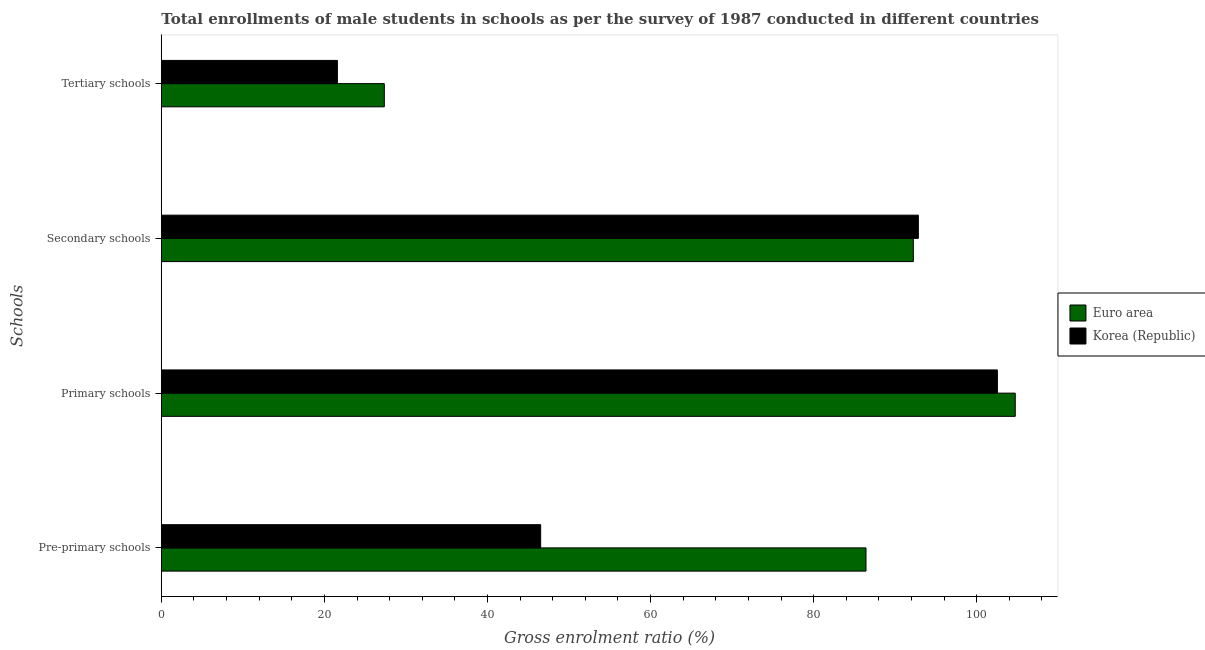How many different coloured bars are there?
Offer a terse response. 2. How many bars are there on the 1st tick from the top?
Your answer should be compact. 2. How many bars are there on the 3rd tick from the bottom?
Your answer should be very brief. 2. What is the label of the 3rd group of bars from the top?
Your response must be concise. Primary schools. What is the gross enrolment ratio(male) in secondary schools in Euro area?
Provide a succinct answer. 92.23. Across all countries, what is the maximum gross enrolment ratio(male) in secondary schools?
Your answer should be very brief. 92.85. Across all countries, what is the minimum gross enrolment ratio(male) in pre-primary schools?
Your answer should be compact. 46.52. In which country was the gross enrolment ratio(male) in secondary schools maximum?
Provide a short and direct response. Korea (Republic). What is the total gross enrolment ratio(male) in tertiary schools in the graph?
Offer a terse response. 48.94. What is the difference between the gross enrolment ratio(male) in primary schools in Euro area and that in Korea (Republic)?
Provide a short and direct response. 2.19. What is the difference between the gross enrolment ratio(male) in secondary schools in Euro area and the gross enrolment ratio(male) in pre-primary schools in Korea (Republic)?
Ensure brevity in your answer.  45.71. What is the average gross enrolment ratio(male) in secondary schools per country?
Your response must be concise. 92.54. What is the difference between the gross enrolment ratio(male) in primary schools and gross enrolment ratio(male) in pre-primary schools in Euro area?
Ensure brevity in your answer.  18.3. What is the ratio of the gross enrolment ratio(male) in secondary schools in Korea (Republic) to that in Euro area?
Ensure brevity in your answer.  1.01. Is the gross enrolment ratio(male) in primary schools in Korea (Republic) less than that in Euro area?
Provide a succinct answer. Yes. What is the difference between the highest and the second highest gross enrolment ratio(male) in primary schools?
Make the answer very short. 2.19. What is the difference between the highest and the lowest gross enrolment ratio(male) in pre-primary schools?
Your response must be concise. 39.9. In how many countries, is the gross enrolment ratio(male) in tertiary schools greater than the average gross enrolment ratio(male) in tertiary schools taken over all countries?
Give a very brief answer. 1. Is the sum of the gross enrolment ratio(male) in pre-primary schools in Euro area and Korea (Republic) greater than the maximum gross enrolment ratio(male) in primary schools across all countries?
Your answer should be very brief. Yes. Is it the case that in every country, the sum of the gross enrolment ratio(male) in tertiary schools and gross enrolment ratio(male) in secondary schools is greater than the sum of gross enrolment ratio(male) in pre-primary schools and gross enrolment ratio(male) in primary schools?
Offer a terse response. Yes. What does the 2nd bar from the bottom in Tertiary schools represents?
Your answer should be very brief. Korea (Republic). What is the difference between two consecutive major ticks on the X-axis?
Ensure brevity in your answer.  20. Does the graph contain any zero values?
Ensure brevity in your answer.  No. Where does the legend appear in the graph?
Provide a succinct answer. Center right. What is the title of the graph?
Give a very brief answer. Total enrollments of male students in schools as per the survey of 1987 conducted in different countries. Does "Senegal" appear as one of the legend labels in the graph?
Give a very brief answer. No. What is the label or title of the Y-axis?
Provide a short and direct response. Schools. What is the Gross enrolment ratio (%) in Euro area in Pre-primary schools?
Make the answer very short. 86.42. What is the Gross enrolment ratio (%) in Korea (Republic) in Pre-primary schools?
Keep it short and to the point. 46.52. What is the Gross enrolment ratio (%) in Euro area in Primary schools?
Provide a short and direct response. 104.73. What is the Gross enrolment ratio (%) in Korea (Republic) in Primary schools?
Give a very brief answer. 102.54. What is the Gross enrolment ratio (%) of Euro area in Secondary schools?
Your answer should be very brief. 92.23. What is the Gross enrolment ratio (%) of Korea (Republic) in Secondary schools?
Offer a very short reply. 92.85. What is the Gross enrolment ratio (%) in Euro area in Tertiary schools?
Offer a very short reply. 27.35. What is the Gross enrolment ratio (%) of Korea (Republic) in Tertiary schools?
Your answer should be compact. 21.59. Across all Schools, what is the maximum Gross enrolment ratio (%) in Euro area?
Your response must be concise. 104.73. Across all Schools, what is the maximum Gross enrolment ratio (%) in Korea (Republic)?
Give a very brief answer. 102.54. Across all Schools, what is the minimum Gross enrolment ratio (%) in Euro area?
Ensure brevity in your answer.  27.35. Across all Schools, what is the minimum Gross enrolment ratio (%) of Korea (Republic)?
Offer a terse response. 21.59. What is the total Gross enrolment ratio (%) of Euro area in the graph?
Keep it short and to the point. 310.73. What is the total Gross enrolment ratio (%) in Korea (Republic) in the graph?
Ensure brevity in your answer.  263.5. What is the difference between the Gross enrolment ratio (%) of Euro area in Pre-primary schools and that in Primary schools?
Offer a very short reply. -18.3. What is the difference between the Gross enrolment ratio (%) of Korea (Republic) in Pre-primary schools and that in Primary schools?
Your answer should be very brief. -56.01. What is the difference between the Gross enrolment ratio (%) of Euro area in Pre-primary schools and that in Secondary schools?
Offer a terse response. -5.81. What is the difference between the Gross enrolment ratio (%) of Korea (Republic) in Pre-primary schools and that in Secondary schools?
Provide a succinct answer. -46.32. What is the difference between the Gross enrolment ratio (%) in Euro area in Pre-primary schools and that in Tertiary schools?
Your answer should be very brief. 59.07. What is the difference between the Gross enrolment ratio (%) in Korea (Republic) in Pre-primary schools and that in Tertiary schools?
Your answer should be compact. 24.93. What is the difference between the Gross enrolment ratio (%) in Euro area in Primary schools and that in Secondary schools?
Make the answer very short. 12.5. What is the difference between the Gross enrolment ratio (%) of Korea (Republic) in Primary schools and that in Secondary schools?
Offer a very short reply. 9.69. What is the difference between the Gross enrolment ratio (%) in Euro area in Primary schools and that in Tertiary schools?
Offer a terse response. 77.38. What is the difference between the Gross enrolment ratio (%) in Korea (Republic) in Primary schools and that in Tertiary schools?
Keep it short and to the point. 80.94. What is the difference between the Gross enrolment ratio (%) in Euro area in Secondary schools and that in Tertiary schools?
Make the answer very short. 64.88. What is the difference between the Gross enrolment ratio (%) in Korea (Republic) in Secondary schools and that in Tertiary schools?
Your answer should be very brief. 71.25. What is the difference between the Gross enrolment ratio (%) of Euro area in Pre-primary schools and the Gross enrolment ratio (%) of Korea (Republic) in Primary schools?
Provide a succinct answer. -16.11. What is the difference between the Gross enrolment ratio (%) in Euro area in Pre-primary schools and the Gross enrolment ratio (%) in Korea (Republic) in Secondary schools?
Your answer should be very brief. -6.42. What is the difference between the Gross enrolment ratio (%) of Euro area in Pre-primary schools and the Gross enrolment ratio (%) of Korea (Republic) in Tertiary schools?
Provide a succinct answer. 64.83. What is the difference between the Gross enrolment ratio (%) of Euro area in Primary schools and the Gross enrolment ratio (%) of Korea (Republic) in Secondary schools?
Your answer should be very brief. 11.88. What is the difference between the Gross enrolment ratio (%) in Euro area in Primary schools and the Gross enrolment ratio (%) in Korea (Republic) in Tertiary schools?
Provide a short and direct response. 83.13. What is the difference between the Gross enrolment ratio (%) in Euro area in Secondary schools and the Gross enrolment ratio (%) in Korea (Republic) in Tertiary schools?
Your answer should be compact. 70.64. What is the average Gross enrolment ratio (%) in Euro area per Schools?
Offer a very short reply. 77.68. What is the average Gross enrolment ratio (%) of Korea (Republic) per Schools?
Offer a very short reply. 65.88. What is the difference between the Gross enrolment ratio (%) in Euro area and Gross enrolment ratio (%) in Korea (Republic) in Pre-primary schools?
Provide a succinct answer. 39.9. What is the difference between the Gross enrolment ratio (%) of Euro area and Gross enrolment ratio (%) of Korea (Republic) in Primary schools?
Keep it short and to the point. 2.19. What is the difference between the Gross enrolment ratio (%) of Euro area and Gross enrolment ratio (%) of Korea (Republic) in Secondary schools?
Your response must be concise. -0.62. What is the difference between the Gross enrolment ratio (%) in Euro area and Gross enrolment ratio (%) in Korea (Republic) in Tertiary schools?
Ensure brevity in your answer.  5.75. What is the ratio of the Gross enrolment ratio (%) of Euro area in Pre-primary schools to that in Primary schools?
Offer a terse response. 0.83. What is the ratio of the Gross enrolment ratio (%) in Korea (Republic) in Pre-primary schools to that in Primary schools?
Provide a succinct answer. 0.45. What is the ratio of the Gross enrolment ratio (%) of Euro area in Pre-primary schools to that in Secondary schools?
Offer a terse response. 0.94. What is the ratio of the Gross enrolment ratio (%) of Korea (Republic) in Pre-primary schools to that in Secondary schools?
Your answer should be compact. 0.5. What is the ratio of the Gross enrolment ratio (%) in Euro area in Pre-primary schools to that in Tertiary schools?
Make the answer very short. 3.16. What is the ratio of the Gross enrolment ratio (%) in Korea (Republic) in Pre-primary schools to that in Tertiary schools?
Give a very brief answer. 2.15. What is the ratio of the Gross enrolment ratio (%) in Euro area in Primary schools to that in Secondary schools?
Make the answer very short. 1.14. What is the ratio of the Gross enrolment ratio (%) in Korea (Republic) in Primary schools to that in Secondary schools?
Your answer should be very brief. 1.1. What is the ratio of the Gross enrolment ratio (%) in Euro area in Primary schools to that in Tertiary schools?
Offer a terse response. 3.83. What is the ratio of the Gross enrolment ratio (%) in Korea (Republic) in Primary schools to that in Tertiary schools?
Your answer should be compact. 4.75. What is the ratio of the Gross enrolment ratio (%) of Euro area in Secondary schools to that in Tertiary schools?
Provide a short and direct response. 3.37. What is the ratio of the Gross enrolment ratio (%) of Korea (Republic) in Secondary schools to that in Tertiary schools?
Offer a very short reply. 4.3. What is the difference between the highest and the second highest Gross enrolment ratio (%) in Euro area?
Your answer should be very brief. 12.5. What is the difference between the highest and the second highest Gross enrolment ratio (%) in Korea (Republic)?
Your response must be concise. 9.69. What is the difference between the highest and the lowest Gross enrolment ratio (%) of Euro area?
Offer a terse response. 77.38. What is the difference between the highest and the lowest Gross enrolment ratio (%) in Korea (Republic)?
Offer a very short reply. 80.94. 